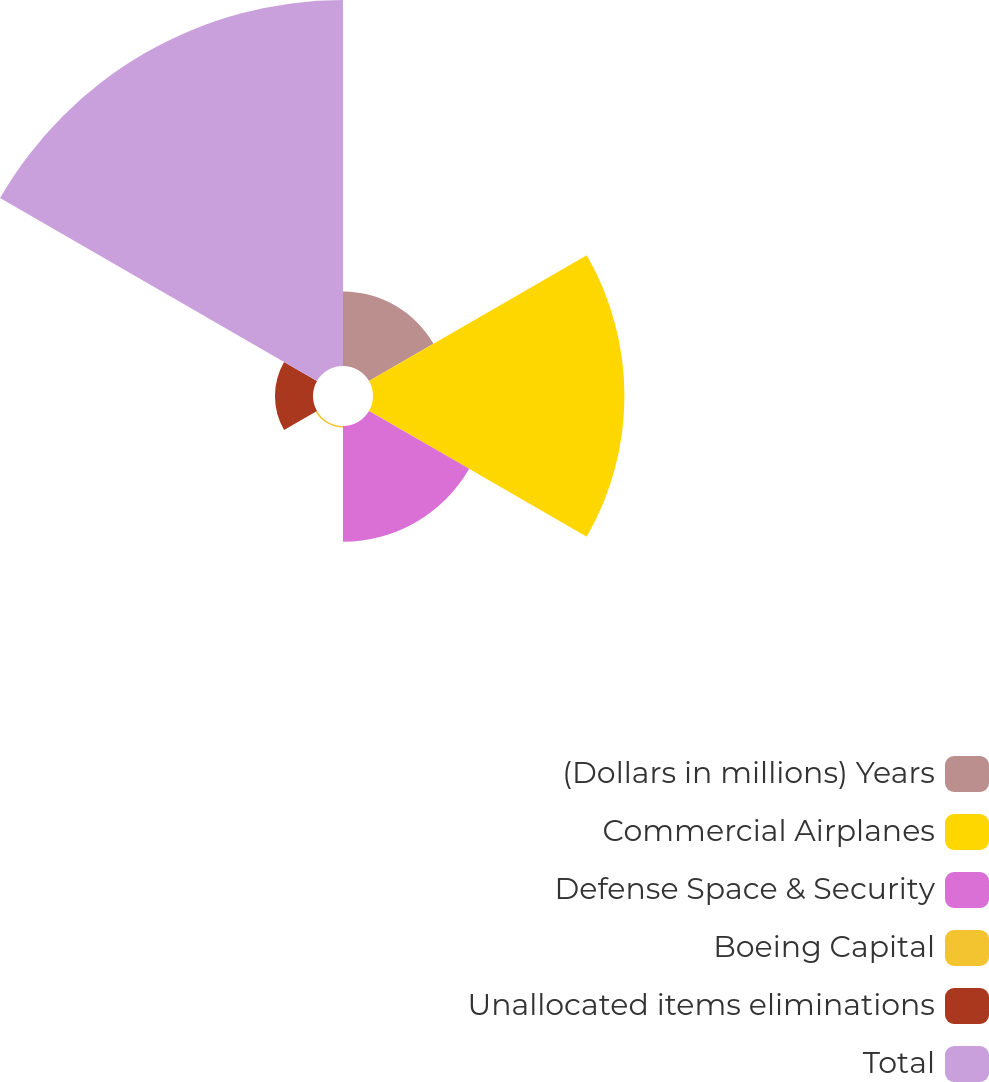Convert chart. <chart><loc_0><loc_0><loc_500><loc_500><pie_chart><fcel>(Dollars in millions) Years<fcel>Commercial Airplanes<fcel>Defense Space & Security<fcel>Boeing Capital<fcel>Unallocated items eliminations<fcel>Total<nl><fcel>8.79%<fcel>29.68%<fcel>13.66%<fcel>0.19%<fcel>4.49%<fcel>43.2%<nl></chart> 